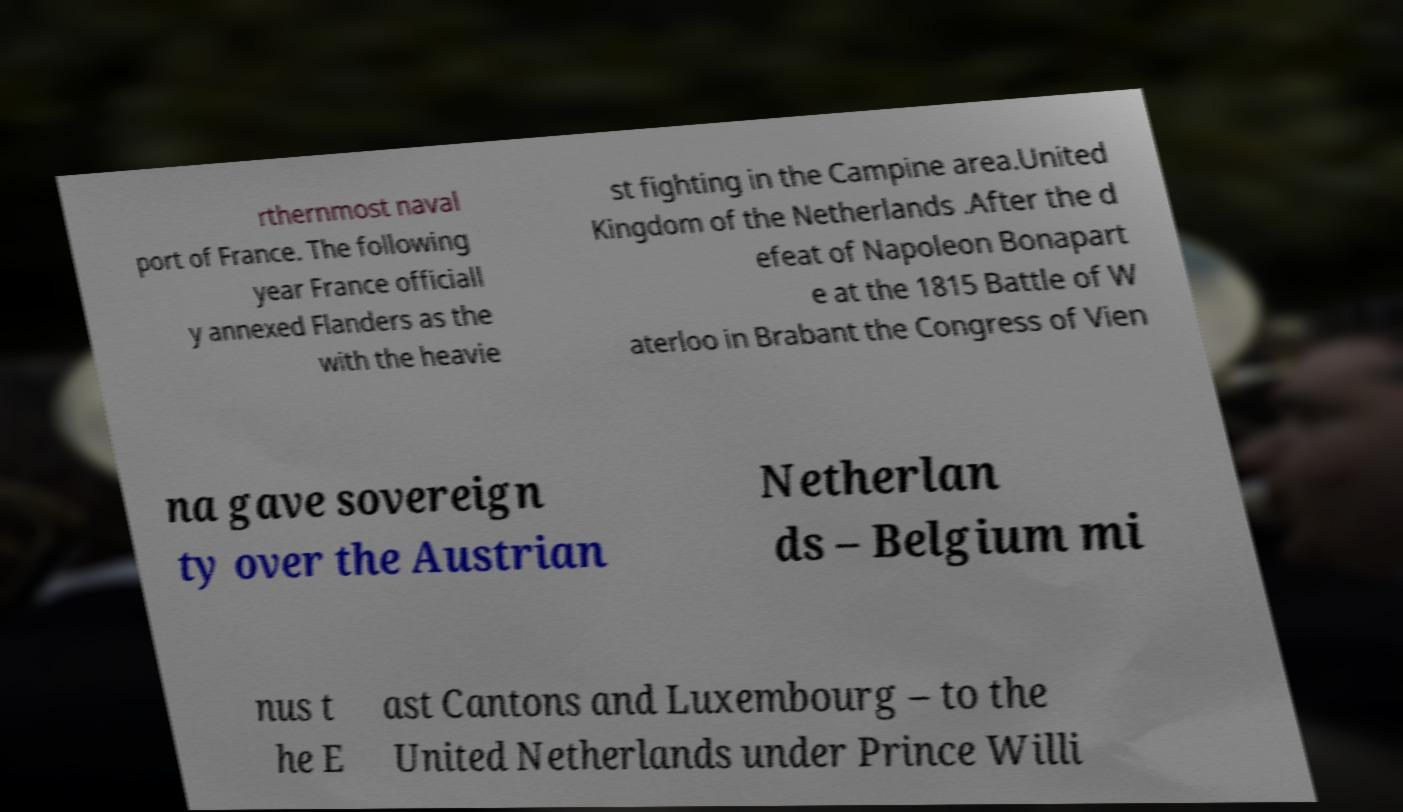I need the written content from this picture converted into text. Can you do that? rthernmost naval port of France. The following year France officiall y annexed Flanders as the with the heavie st fighting in the Campine area.United Kingdom of the Netherlands .After the d efeat of Napoleon Bonapart e at the 1815 Battle of W aterloo in Brabant the Congress of Vien na gave sovereign ty over the Austrian Netherlan ds – Belgium mi nus t he E ast Cantons and Luxembourg – to the United Netherlands under Prince Willi 